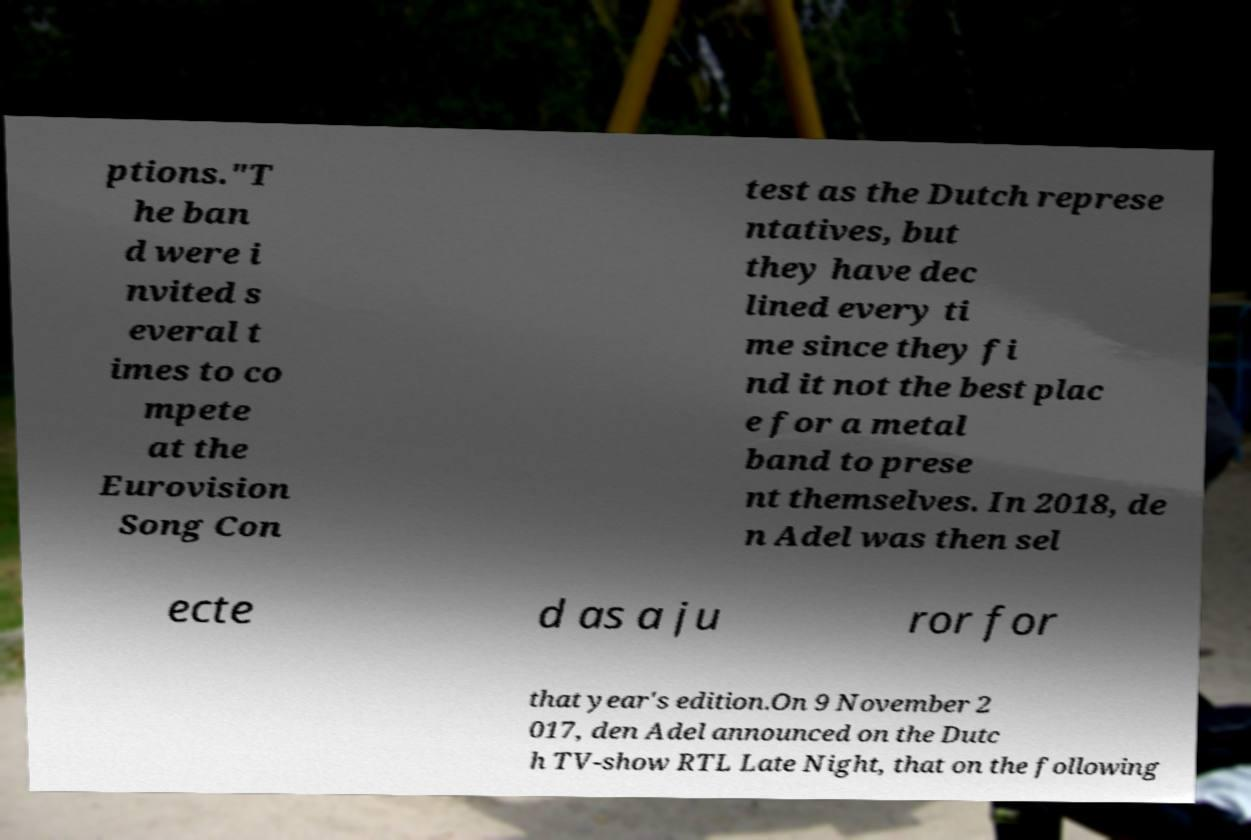Could you assist in decoding the text presented in this image and type it out clearly? ptions."T he ban d were i nvited s everal t imes to co mpete at the Eurovision Song Con test as the Dutch represe ntatives, but they have dec lined every ti me since they fi nd it not the best plac e for a metal band to prese nt themselves. In 2018, de n Adel was then sel ecte d as a ju ror for that year's edition.On 9 November 2 017, den Adel announced on the Dutc h TV-show RTL Late Night, that on the following 